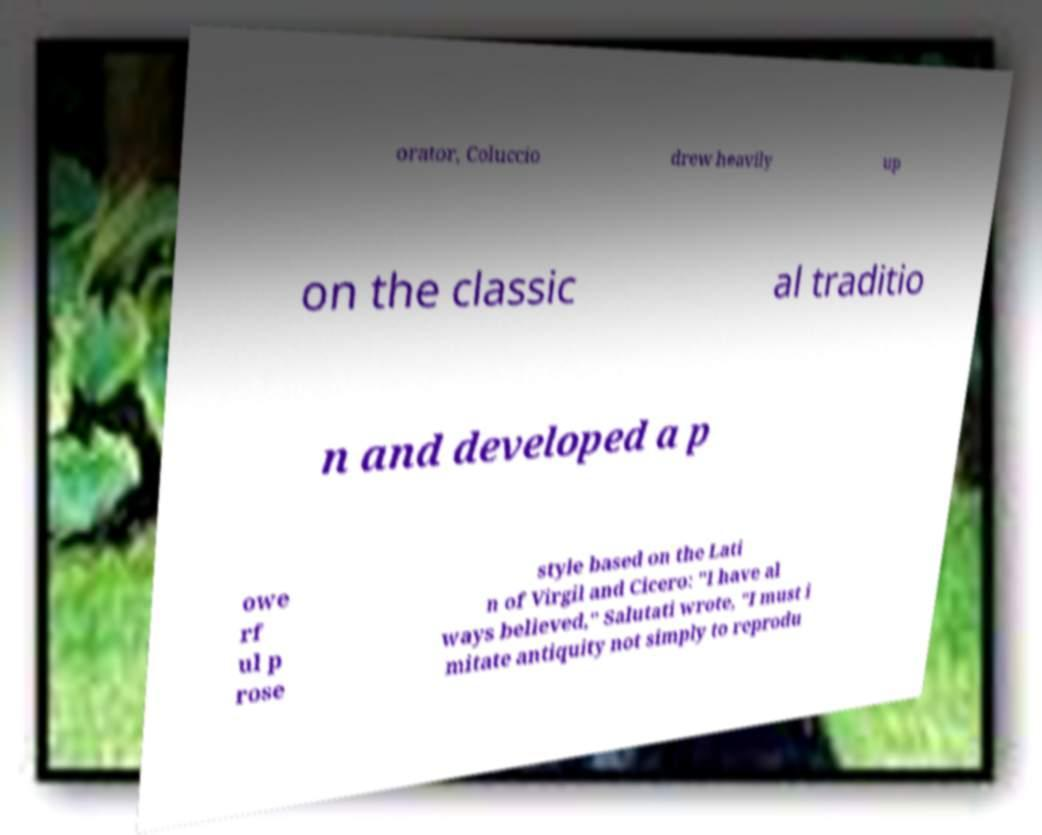Please read and relay the text visible in this image. What does it say? orator, Coluccio drew heavily up on the classic al traditio n and developed a p owe rf ul p rose style based on the Lati n of Virgil and Cicero: "I have al ways believed," Salutati wrote, "I must i mitate antiquity not simply to reprodu 